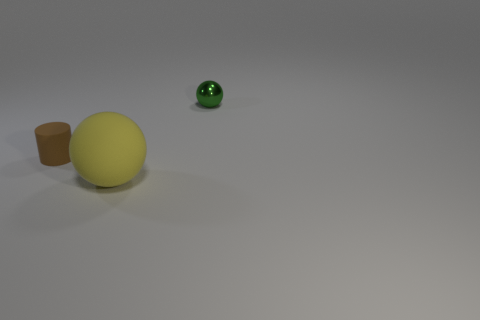Add 1 big rubber objects. How many objects exist? 4 Subtract all cylinders. How many objects are left? 2 Add 3 small blue metal balls. How many small blue metal balls exist? 3 Subtract 0 blue cubes. How many objects are left? 3 Subtract all small rubber things. Subtract all green metal spheres. How many objects are left? 1 Add 3 small cylinders. How many small cylinders are left? 4 